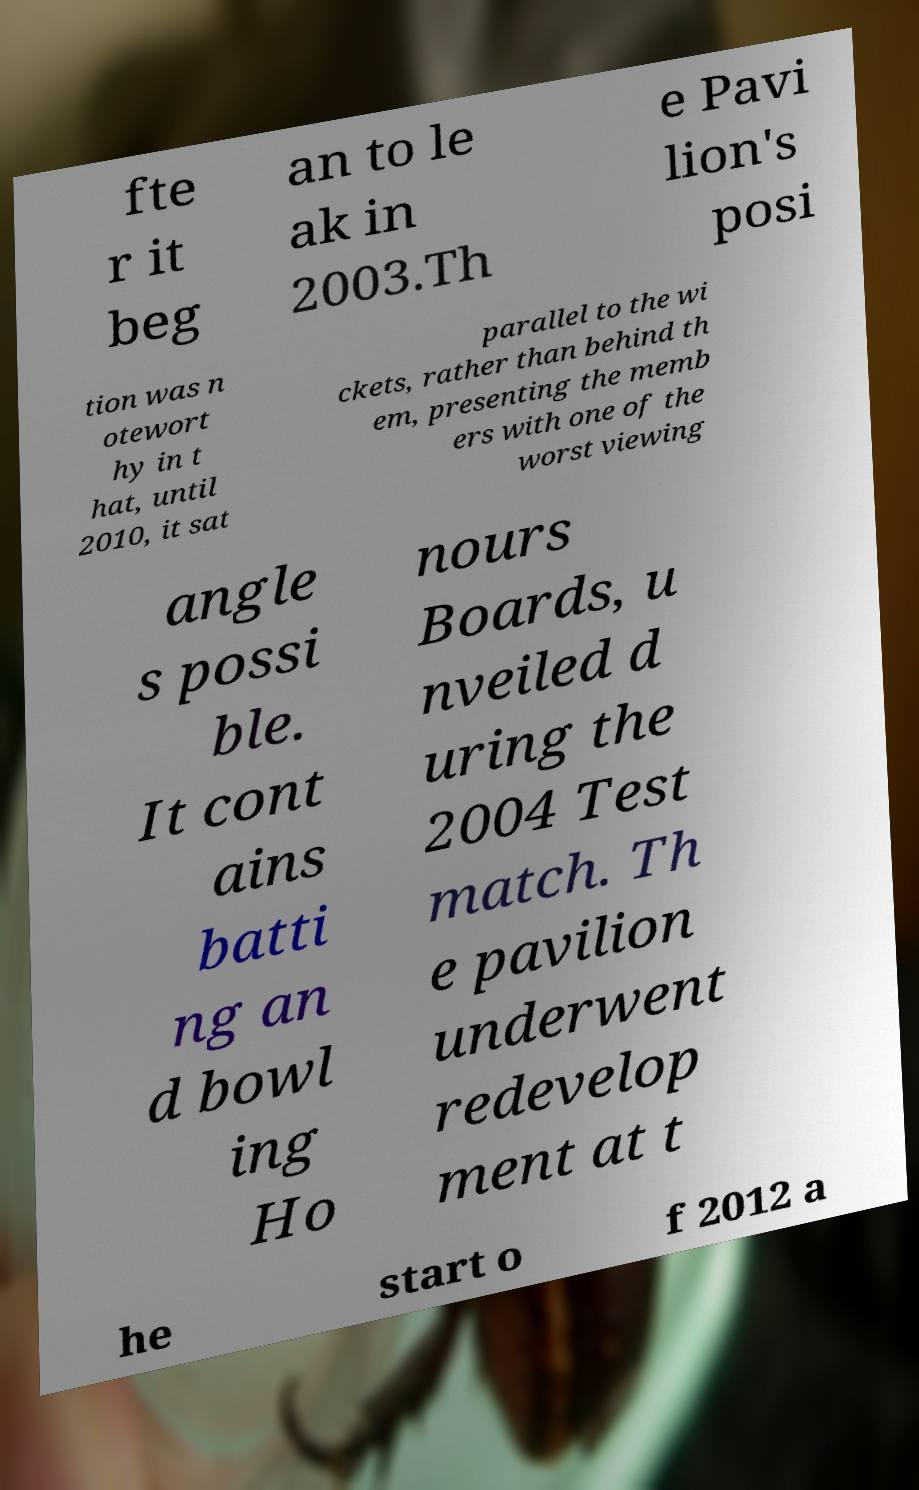What messages or text are displayed in this image? I need them in a readable, typed format. fte r it beg an to le ak in 2003.Th e Pavi lion's posi tion was n otewort hy in t hat, until 2010, it sat parallel to the wi ckets, rather than behind th em, presenting the memb ers with one of the worst viewing angle s possi ble. It cont ains batti ng an d bowl ing Ho nours Boards, u nveiled d uring the 2004 Test match. Th e pavilion underwent redevelop ment at t he start o f 2012 a 